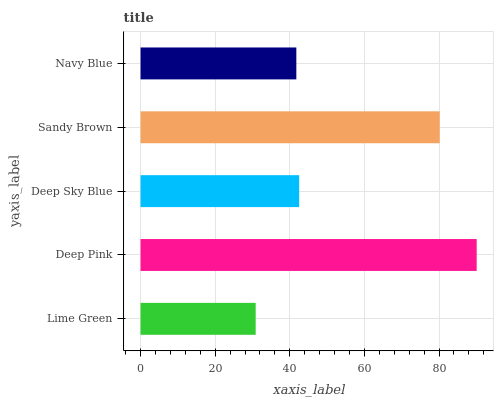Is Lime Green the minimum?
Answer yes or no. Yes. Is Deep Pink the maximum?
Answer yes or no. Yes. Is Deep Sky Blue the minimum?
Answer yes or no. No. Is Deep Sky Blue the maximum?
Answer yes or no. No. Is Deep Pink greater than Deep Sky Blue?
Answer yes or no. Yes. Is Deep Sky Blue less than Deep Pink?
Answer yes or no. Yes. Is Deep Sky Blue greater than Deep Pink?
Answer yes or no. No. Is Deep Pink less than Deep Sky Blue?
Answer yes or no. No. Is Deep Sky Blue the high median?
Answer yes or no. Yes. Is Deep Sky Blue the low median?
Answer yes or no. Yes. Is Deep Pink the high median?
Answer yes or no. No. Is Lime Green the low median?
Answer yes or no. No. 